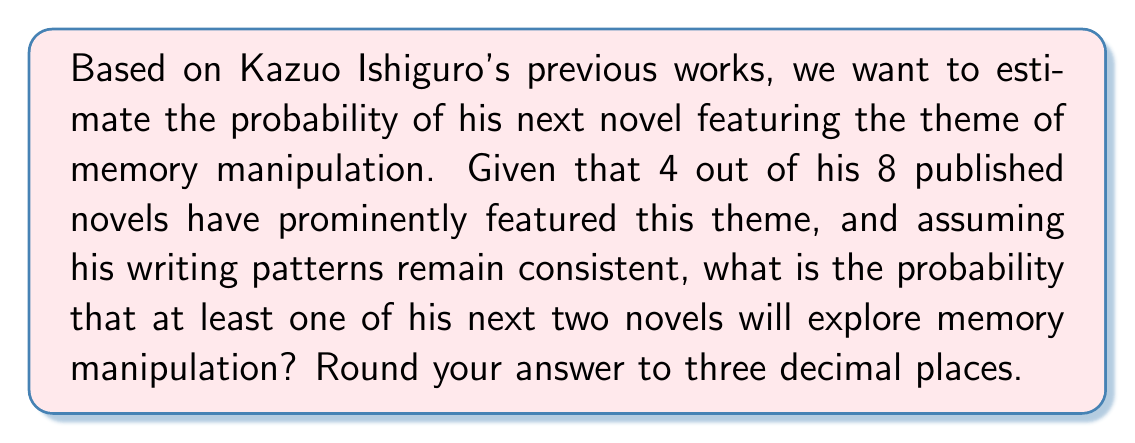Can you solve this math problem? Let's approach this step-by-step using probability theory:

1) First, let's define our probability:
   $p$ = probability of a single novel featuring memory manipulation
   $p = \frac{4}{8} = 0.5$

2) We want to find the probability of at least one of the next two novels featuring this theme. It's easier to calculate the probability of neither novel featuring it and then subtract from 1.

3) Probability of a single novel not featuring memory manipulation:
   $1 - p = 1 - 0.5 = 0.5$

4) Probability of neither of the two novels featuring memory manipulation:
   $(1-p)^2 = (0.5)^2 = 0.25$

5) Therefore, the probability of at least one of the two novels featuring memory manipulation is:
   $1 - (1-p)^2 = 1 - 0.25 = 0.75$

6) Rounding to three decimal places:
   $0.75 = 0.750$

This calculation assumes that each novel is an independent event and that Ishiguro's writing patterns remain consistent with his past work.
Answer: 0.750 